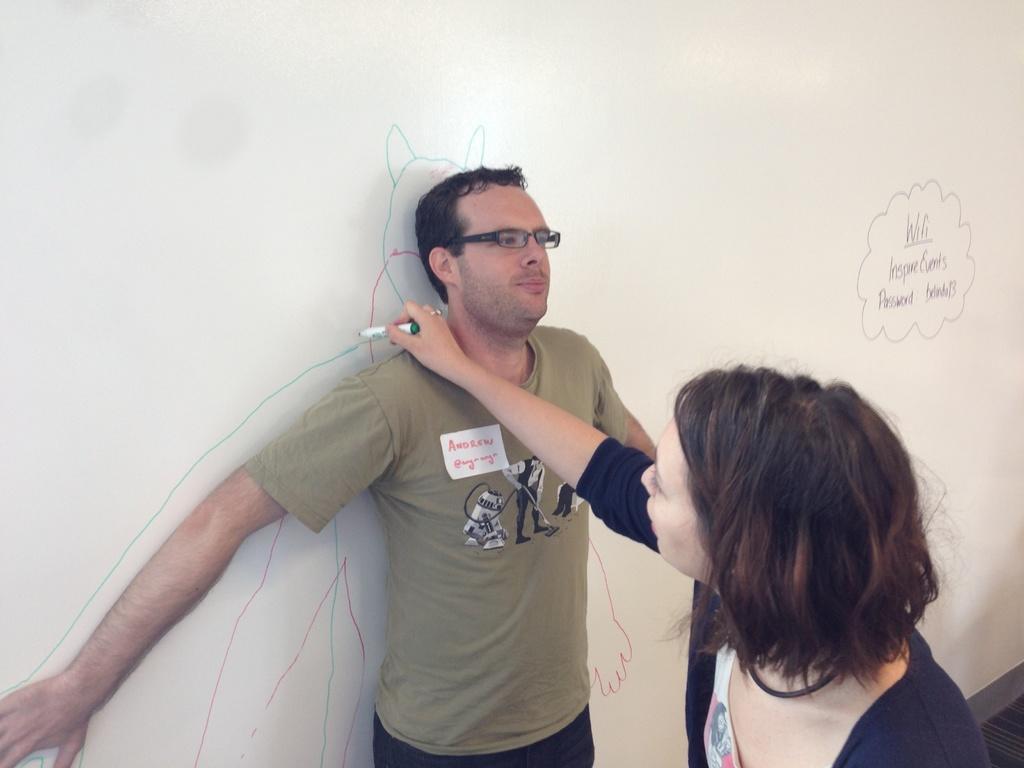Please provide a concise description of this image. In the center of the image there is a person standing at the board. On the right side of the image we can see a woman writing on the board. In the background there is a board. 